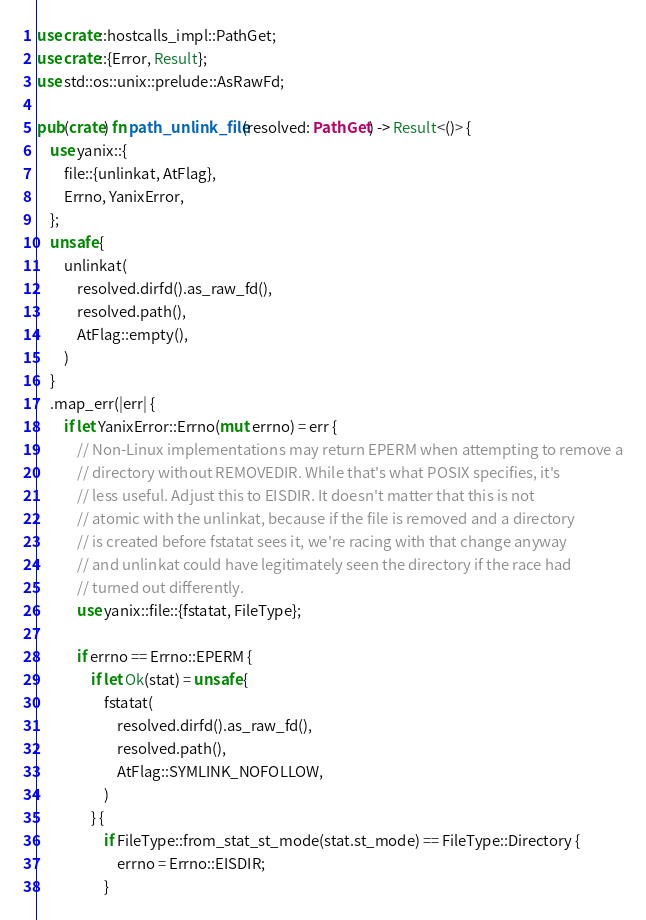Convert code to text. <code><loc_0><loc_0><loc_500><loc_500><_Rust_>use crate::hostcalls_impl::PathGet;
use crate::{Error, Result};
use std::os::unix::prelude::AsRawFd;

pub(crate) fn path_unlink_file(resolved: PathGet) -> Result<()> {
    use yanix::{
        file::{unlinkat, AtFlag},
        Errno, YanixError,
    };
    unsafe {
        unlinkat(
            resolved.dirfd().as_raw_fd(),
            resolved.path(),
            AtFlag::empty(),
        )
    }
    .map_err(|err| {
        if let YanixError::Errno(mut errno) = err {
            // Non-Linux implementations may return EPERM when attempting to remove a
            // directory without REMOVEDIR. While that's what POSIX specifies, it's
            // less useful. Adjust this to EISDIR. It doesn't matter that this is not
            // atomic with the unlinkat, because if the file is removed and a directory
            // is created before fstatat sees it, we're racing with that change anyway
            // and unlinkat could have legitimately seen the directory if the race had
            // turned out differently.
            use yanix::file::{fstatat, FileType};

            if errno == Errno::EPERM {
                if let Ok(stat) = unsafe {
                    fstatat(
                        resolved.dirfd().as_raw_fd(),
                        resolved.path(),
                        AtFlag::SYMLINK_NOFOLLOW,
                    )
                } {
                    if FileType::from_stat_st_mode(stat.st_mode) == FileType::Directory {
                        errno = Errno::EISDIR;
                    }</code> 